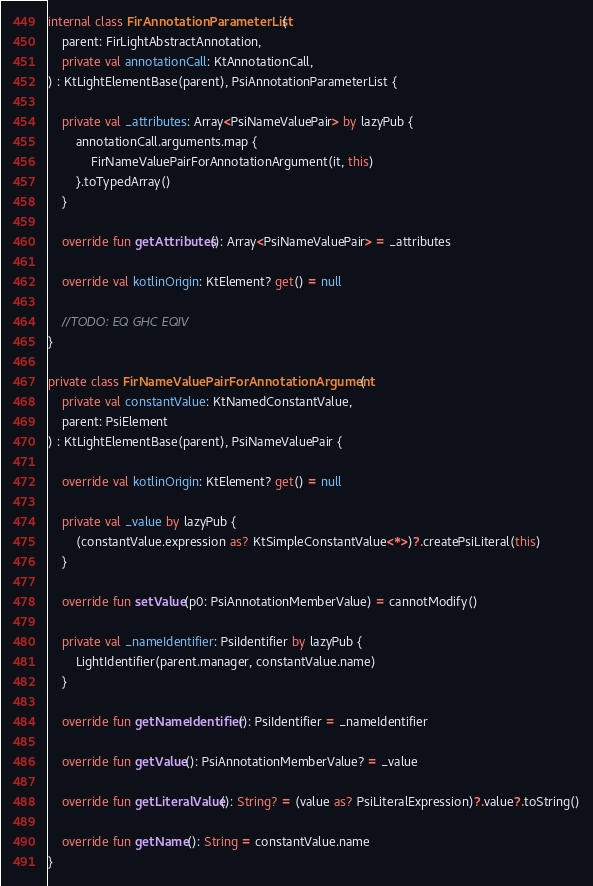<code> <loc_0><loc_0><loc_500><loc_500><_Kotlin_>internal class FirAnnotationParameterList(
    parent: FirLightAbstractAnnotation,
    private val annotationCall: KtAnnotationCall,
) : KtLightElementBase(parent), PsiAnnotationParameterList {

    private val _attributes: Array<PsiNameValuePair> by lazyPub {
        annotationCall.arguments.map {
            FirNameValuePairForAnnotationArgument(it, this)
        }.toTypedArray()
    }

    override fun getAttributes(): Array<PsiNameValuePair> = _attributes

    override val kotlinOrigin: KtElement? get() = null

    //TODO: EQ GHC EQIV
}

private class FirNameValuePairForAnnotationArgument(
    private val constantValue: KtNamedConstantValue,
    parent: PsiElement
) : KtLightElementBase(parent), PsiNameValuePair {

    override val kotlinOrigin: KtElement? get() = null

    private val _value by lazyPub {
        (constantValue.expression as? KtSimpleConstantValue<*>)?.createPsiLiteral(this)
    }

    override fun setValue(p0: PsiAnnotationMemberValue) = cannotModify()

    private val _nameIdentifier: PsiIdentifier by lazyPub {
        LightIdentifier(parent.manager, constantValue.name)
    }

    override fun getNameIdentifier(): PsiIdentifier = _nameIdentifier

    override fun getValue(): PsiAnnotationMemberValue? = _value

    override fun getLiteralValue(): String? = (value as? PsiLiteralExpression)?.value?.toString()

    override fun getName(): String = constantValue.name
}</code> 